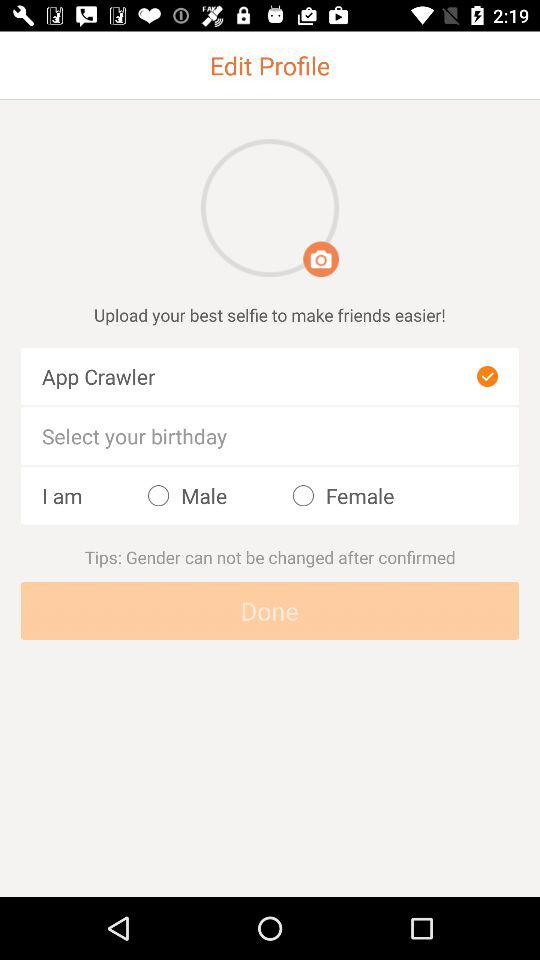What is the user name? The user name is App Crawler. 